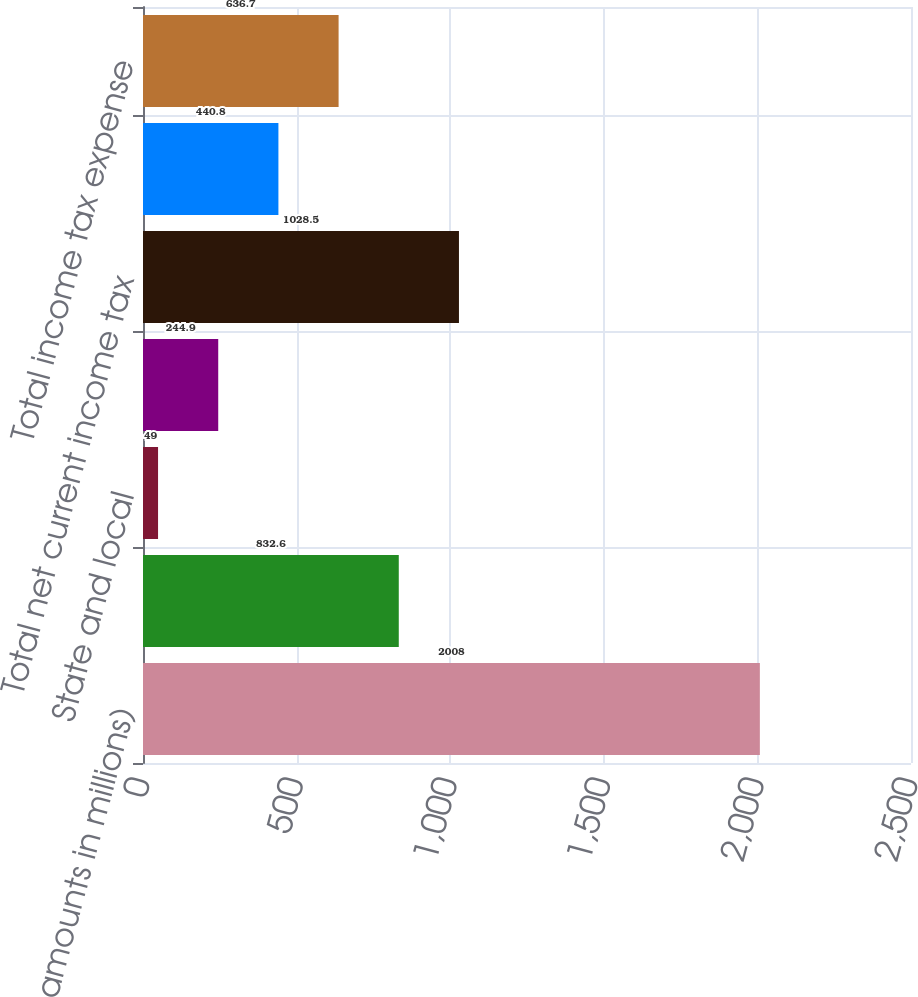Convert chart to OTSL. <chart><loc_0><loc_0><loc_500><loc_500><bar_chart><fcel>(Dollar amounts in millions)<fcel>Federal<fcel>State and local<fcel>Foreign<fcel>Total net current income tax<fcel>Total net deferred income tax<fcel>Total income tax expense<nl><fcel>2008<fcel>832.6<fcel>49<fcel>244.9<fcel>1028.5<fcel>440.8<fcel>636.7<nl></chart> 